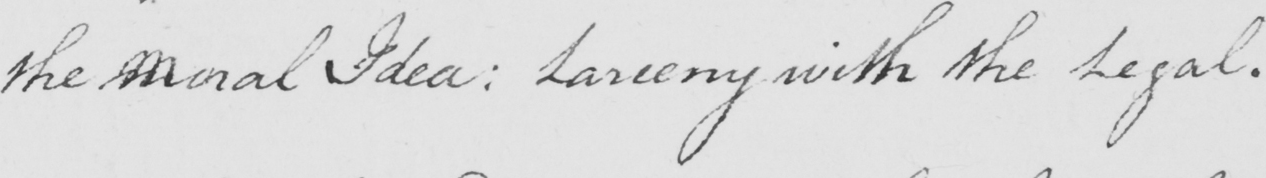Please provide the text content of this handwritten line. the Moral Idea :  Larceny with the Legal . 